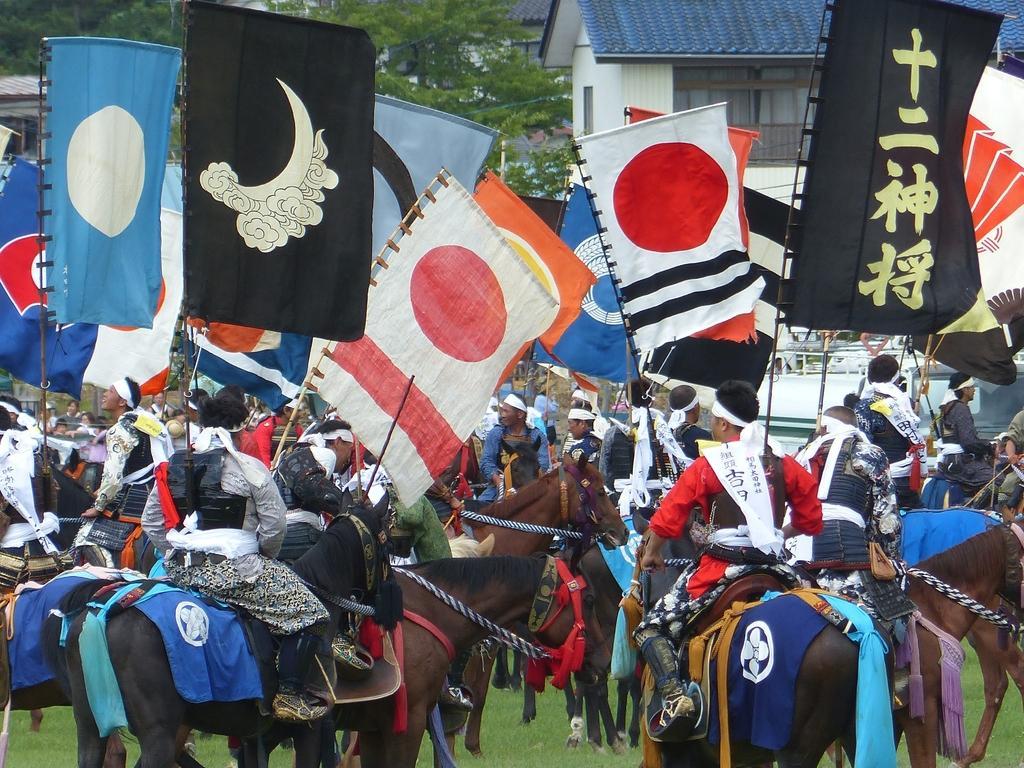How would you summarize this image in a sentence or two? Here in this picture we can see number of people sitting on horses, in traditional dresses and all of them are holding flag posts in their hand and in the front we can see houses present and we can see trees all over there and we can see the ground is covered with grass over there. 